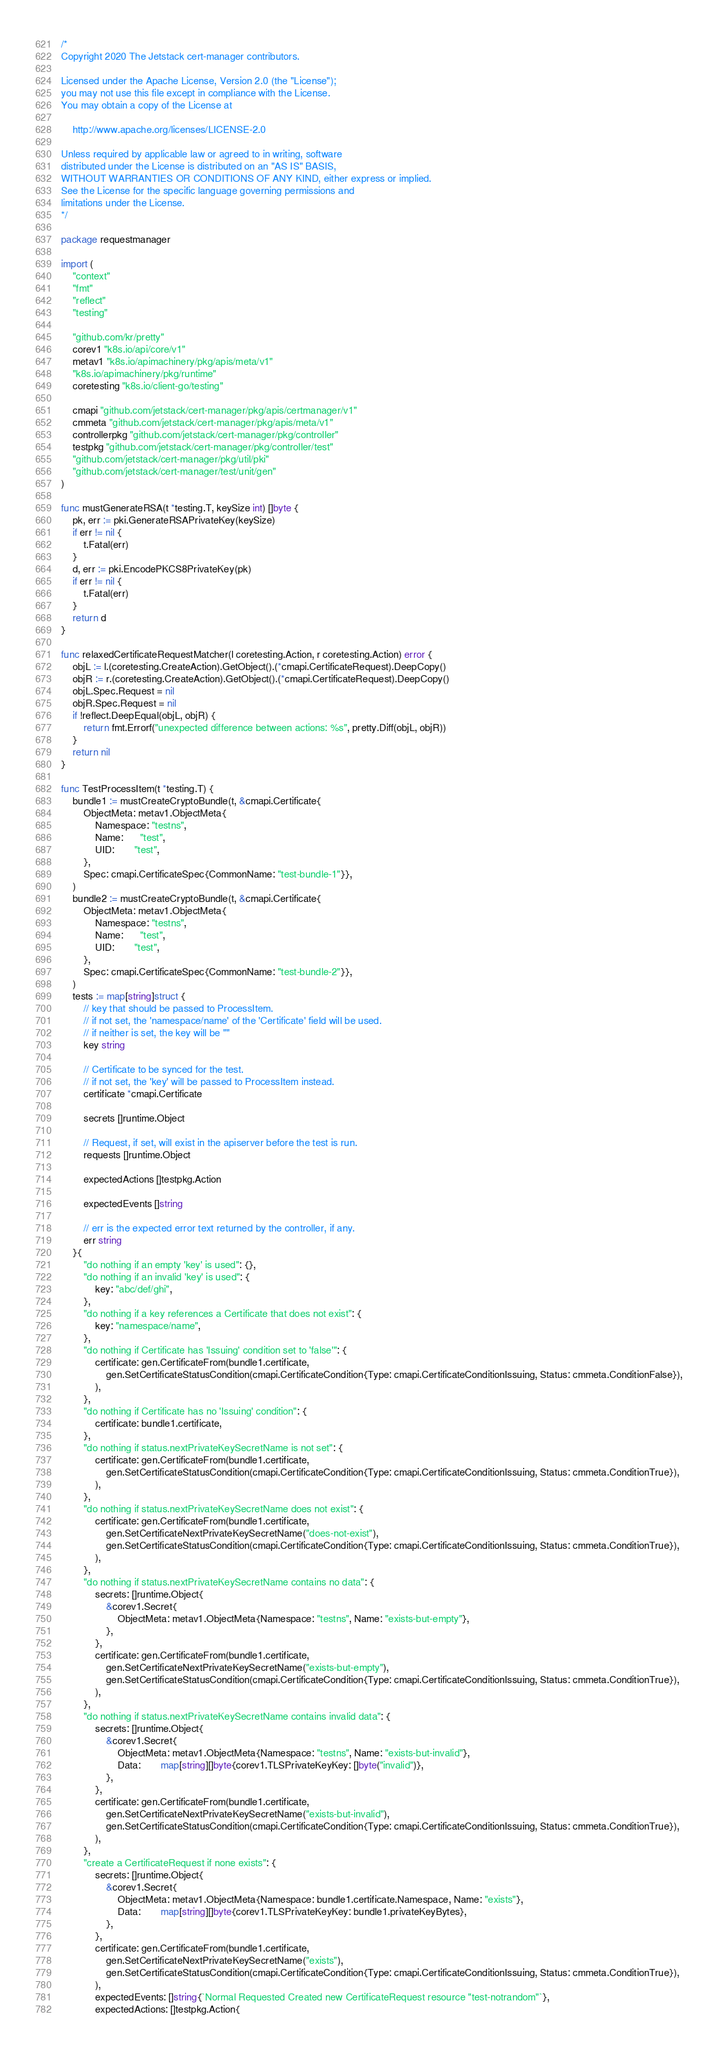<code> <loc_0><loc_0><loc_500><loc_500><_Go_>/*
Copyright 2020 The Jetstack cert-manager contributors.

Licensed under the Apache License, Version 2.0 (the "License");
you may not use this file except in compliance with the License.
You may obtain a copy of the License at

    http://www.apache.org/licenses/LICENSE-2.0

Unless required by applicable law or agreed to in writing, software
distributed under the License is distributed on an "AS IS" BASIS,
WITHOUT WARRANTIES OR CONDITIONS OF ANY KIND, either express or implied.
See the License for the specific language governing permissions and
limitations under the License.
*/

package requestmanager

import (
	"context"
	"fmt"
	"reflect"
	"testing"

	"github.com/kr/pretty"
	corev1 "k8s.io/api/core/v1"
	metav1 "k8s.io/apimachinery/pkg/apis/meta/v1"
	"k8s.io/apimachinery/pkg/runtime"
	coretesting "k8s.io/client-go/testing"

	cmapi "github.com/jetstack/cert-manager/pkg/apis/certmanager/v1"
	cmmeta "github.com/jetstack/cert-manager/pkg/apis/meta/v1"
	controllerpkg "github.com/jetstack/cert-manager/pkg/controller"
	testpkg "github.com/jetstack/cert-manager/pkg/controller/test"
	"github.com/jetstack/cert-manager/pkg/util/pki"
	"github.com/jetstack/cert-manager/test/unit/gen"
)

func mustGenerateRSA(t *testing.T, keySize int) []byte {
	pk, err := pki.GenerateRSAPrivateKey(keySize)
	if err != nil {
		t.Fatal(err)
	}
	d, err := pki.EncodePKCS8PrivateKey(pk)
	if err != nil {
		t.Fatal(err)
	}
	return d
}

func relaxedCertificateRequestMatcher(l coretesting.Action, r coretesting.Action) error {
	objL := l.(coretesting.CreateAction).GetObject().(*cmapi.CertificateRequest).DeepCopy()
	objR := r.(coretesting.CreateAction).GetObject().(*cmapi.CertificateRequest).DeepCopy()
	objL.Spec.Request = nil
	objR.Spec.Request = nil
	if !reflect.DeepEqual(objL, objR) {
		return fmt.Errorf("unexpected difference between actions: %s", pretty.Diff(objL, objR))
	}
	return nil
}

func TestProcessItem(t *testing.T) {
	bundle1 := mustCreateCryptoBundle(t, &cmapi.Certificate{
		ObjectMeta: metav1.ObjectMeta{
			Namespace: "testns",
			Name:      "test",
			UID:       "test",
		},
		Spec: cmapi.CertificateSpec{CommonName: "test-bundle-1"}},
	)
	bundle2 := mustCreateCryptoBundle(t, &cmapi.Certificate{
		ObjectMeta: metav1.ObjectMeta{
			Namespace: "testns",
			Name:      "test",
			UID:       "test",
		},
		Spec: cmapi.CertificateSpec{CommonName: "test-bundle-2"}},
	)
	tests := map[string]struct {
		// key that should be passed to ProcessItem.
		// if not set, the 'namespace/name' of the 'Certificate' field will be used.
		// if neither is set, the key will be ""
		key string

		// Certificate to be synced for the test.
		// if not set, the 'key' will be passed to ProcessItem instead.
		certificate *cmapi.Certificate

		secrets []runtime.Object

		// Request, if set, will exist in the apiserver before the test is run.
		requests []runtime.Object

		expectedActions []testpkg.Action

		expectedEvents []string

		// err is the expected error text returned by the controller, if any.
		err string
	}{
		"do nothing if an empty 'key' is used": {},
		"do nothing if an invalid 'key' is used": {
			key: "abc/def/ghi",
		},
		"do nothing if a key references a Certificate that does not exist": {
			key: "namespace/name",
		},
		"do nothing if Certificate has 'Issuing' condition set to 'false'": {
			certificate: gen.CertificateFrom(bundle1.certificate,
				gen.SetCertificateStatusCondition(cmapi.CertificateCondition{Type: cmapi.CertificateConditionIssuing, Status: cmmeta.ConditionFalse}),
			),
		},
		"do nothing if Certificate has no 'Issuing' condition": {
			certificate: bundle1.certificate,
		},
		"do nothing if status.nextPrivateKeySecretName is not set": {
			certificate: gen.CertificateFrom(bundle1.certificate,
				gen.SetCertificateStatusCondition(cmapi.CertificateCondition{Type: cmapi.CertificateConditionIssuing, Status: cmmeta.ConditionTrue}),
			),
		},
		"do nothing if status.nextPrivateKeySecretName does not exist": {
			certificate: gen.CertificateFrom(bundle1.certificate,
				gen.SetCertificateNextPrivateKeySecretName("does-not-exist"),
				gen.SetCertificateStatusCondition(cmapi.CertificateCondition{Type: cmapi.CertificateConditionIssuing, Status: cmmeta.ConditionTrue}),
			),
		},
		"do nothing if status.nextPrivateKeySecretName contains no data": {
			secrets: []runtime.Object{
				&corev1.Secret{
					ObjectMeta: metav1.ObjectMeta{Namespace: "testns", Name: "exists-but-empty"},
				},
			},
			certificate: gen.CertificateFrom(bundle1.certificate,
				gen.SetCertificateNextPrivateKeySecretName("exists-but-empty"),
				gen.SetCertificateStatusCondition(cmapi.CertificateCondition{Type: cmapi.CertificateConditionIssuing, Status: cmmeta.ConditionTrue}),
			),
		},
		"do nothing if status.nextPrivateKeySecretName contains invalid data": {
			secrets: []runtime.Object{
				&corev1.Secret{
					ObjectMeta: metav1.ObjectMeta{Namespace: "testns", Name: "exists-but-invalid"},
					Data:       map[string][]byte{corev1.TLSPrivateKeyKey: []byte("invalid")},
				},
			},
			certificate: gen.CertificateFrom(bundle1.certificate,
				gen.SetCertificateNextPrivateKeySecretName("exists-but-invalid"),
				gen.SetCertificateStatusCondition(cmapi.CertificateCondition{Type: cmapi.CertificateConditionIssuing, Status: cmmeta.ConditionTrue}),
			),
		},
		"create a CertificateRequest if none exists": {
			secrets: []runtime.Object{
				&corev1.Secret{
					ObjectMeta: metav1.ObjectMeta{Namespace: bundle1.certificate.Namespace, Name: "exists"},
					Data:       map[string][]byte{corev1.TLSPrivateKeyKey: bundle1.privateKeyBytes},
				},
			},
			certificate: gen.CertificateFrom(bundle1.certificate,
				gen.SetCertificateNextPrivateKeySecretName("exists"),
				gen.SetCertificateStatusCondition(cmapi.CertificateCondition{Type: cmapi.CertificateConditionIssuing, Status: cmmeta.ConditionTrue}),
			),
			expectedEvents: []string{`Normal Requested Created new CertificateRequest resource "test-notrandom"`},
			expectedActions: []testpkg.Action{</code> 